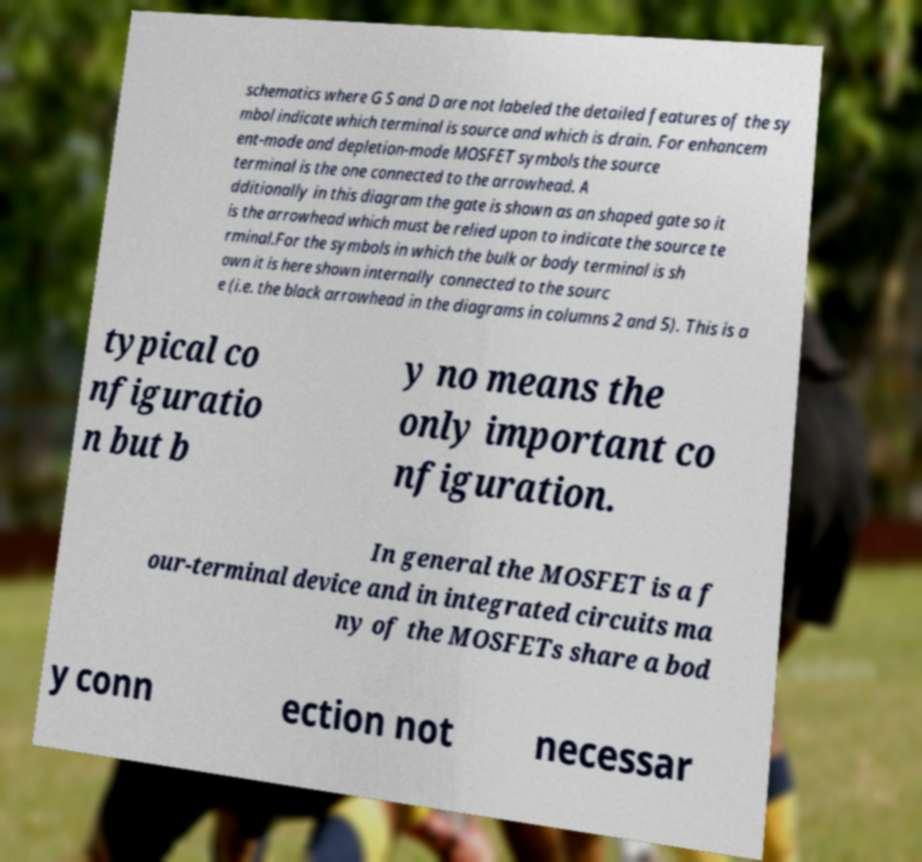Can you read and provide the text displayed in the image?This photo seems to have some interesting text. Can you extract and type it out for me? schematics where G S and D are not labeled the detailed features of the sy mbol indicate which terminal is source and which is drain. For enhancem ent-mode and depletion-mode MOSFET symbols the source terminal is the one connected to the arrowhead. A dditionally in this diagram the gate is shown as an shaped gate so it is the arrowhead which must be relied upon to indicate the source te rminal.For the symbols in which the bulk or body terminal is sh own it is here shown internally connected to the sourc e (i.e. the black arrowhead in the diagrams in columns 2 and 5). This is a typical co nfiguratio n but b y no means the only important co nfiguration. In general the MOSFET is a f our-terminal device and in integrated circuits ma ny of the MOSFETs share a bod y conn ection not necessar 